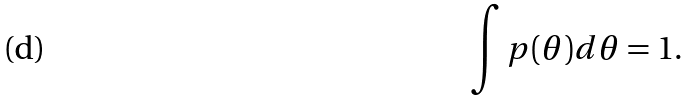<formula> <loc_0><loc_0><loc_500><loc_500>\int p ( \theta ) d \theta = 1 .</formula> 